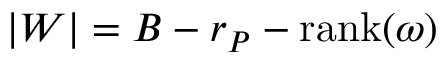<formula> <loc_0><loc_0><loc_500><loc_500>| W | = B - r _ { P } - r a n k ( \omega )</formula> 